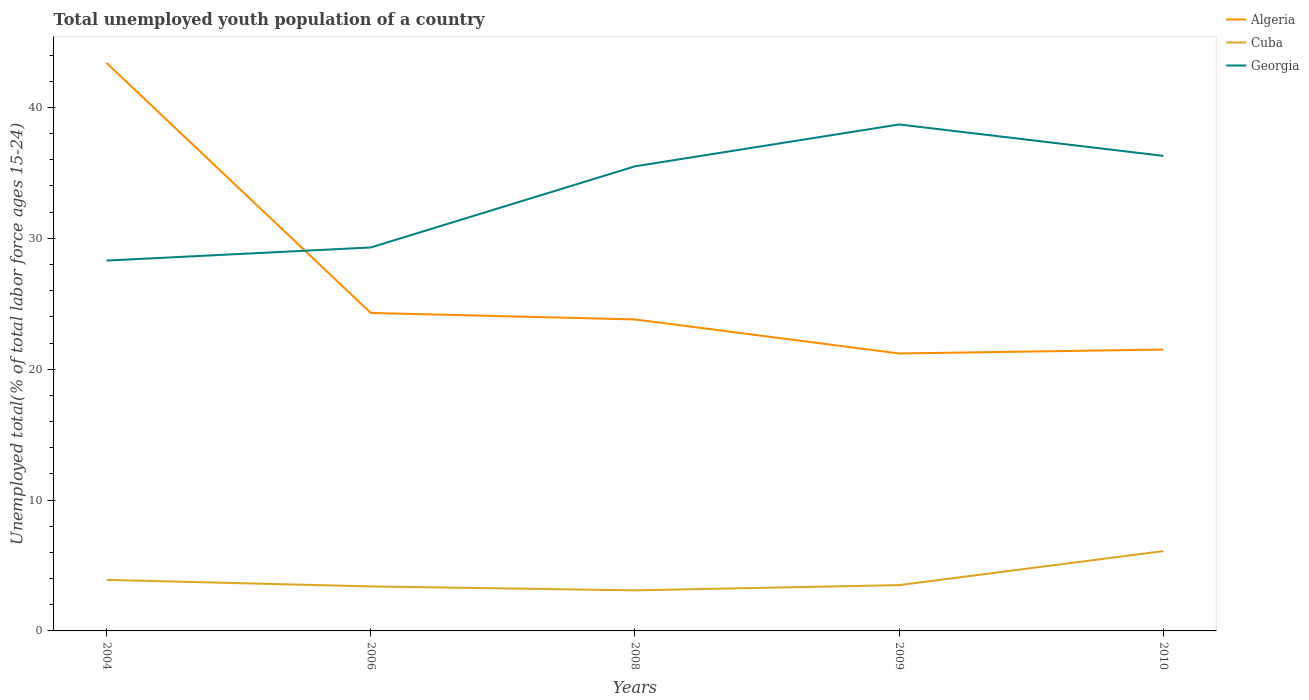How many different coloured lines are there?
Provide a short and direct response. 3. Does the line corresponding to Georgia intersect with the line corresponding to Cuba?
Your response must be concise. No. Is the number of lines equal to the number of legend labels?
Offer a terse response. Yes. Across all years, what is the maximum percentage of total unemployed youth population of a country in Georgia?
Provide a succinct answer. 28.3. In which year was the percentage of total unemployed youth population of a country in Algeria maximum?
Your answer should be compact. 2009. What is the total percentage of total unemployed youth population of a country in Algeria in the graph?
Keep it short and to the point. -0.3. What is the difference between the highest and the second highest percentage of total unemployed youth population of a country in Georgia?
Offer a very short reply. 10.4. What is the difference between the highest and the lowest percentage of total unemployed youth population of a country in Cuba?
Ensure brevity in your answer.  1. How many lines are there?
Ensure brevity in your answer.  3. What is the difference between two consecutive major ticks on the Y-axis?
Offer a terse response. 10. Does the graph contain any zero values?
Offer a very short reply. No. What is the title of the graph?
Provide a succinct answer. Total unemployed youth population of a country. Does "Jordan" appear as one of the legend labels in the graph?
Make the answer very short. No. What is the label or title of the X-axis?
Give a very brief answer. Years. What is the label or title of the Y-axis?
Your answer should be compact. Unemployed total(% of total labor force ages 15-24). What is the Unemployed total(% of total labor force ages 15-24) of Algeria in 2004?
Offer a terse response. 43.4. What is the Unemployed total(% of total labor force ages 15-24) of Cuba in 2004?
Your answer should be compact. 3.9. What is the Unemployed total(% of total labor force ages 15-24) of Georgia in 2004?
Keep it short and to the point. 28.3. What is the Unemployed total(% of total labor force ages 15-24) in Algeria in 2006?
Provide a succinct answer. 24.3. What is the Unemployed total(% of total labor force ages 15-24) of Cuba in 2006?
Ensure brevity in your answer.  3.4. What is the Unemployed total(% of total labor force ages 15-24) in Georgia in 2006?
Offer a very short reply. 29.3. What is the Unemployed total(% of total labor force ages 15-24) in Algeria in 2008?
Offer a very short reply. 23.8. What is the Unemployed total(% of total labor force ages 15-24) in Cuba in 2008?
Keep it short and to the point. 3.1. What is the Unemployed total(% of total labor force ages 15-24) in Georgia in 2008?
Keep it short and to the point. 35.5. What is the Unemployed total(% of total labor force ages 15-24) in Algeria in 2009?
Provide a succinct answer. 21.2. What is the Unemployed total(% of total labor force ages 15-24) of Georgia in 2009?
Provide a succinct answer. 38.7. What is the Unemployed total(% of total labor force ages 15-24) in Cuba in 2010?
Ensure brevity in your answer.  6.1. What is the Unemployed total(% of total labor force ages 15-24) of Georgia in 2010?
Your answer should be compact. 36.3. Across all years, what is the maximum Unemployed total(% of total labor force ages 15-24) in Algeria?
Your response must be concise. 43.4. Across all years, what is the maximum Unemployed total(% of total labor force ages 15-24) in Cuba?
Your answer should be compact. 6.1. Across all years, what is the maximum Unemployed total(% of total labor force ages 15-24) in Georgia?
Your answer should be very brief. 38.7. Across all years, what is the minimum Unemployed total(% of total labor force ages 15-24) in Algeria?
Ensure brevity in your answer.  21.2. Across all years, what is the minimum Unemployed total(% of total labor force ages 15-24) of Cuba?
Your answer should be very brief. 3.1. Across all years, what is the minimum Unemployed total(% of total labor force ages 15-24) of Georgia?
Offer a very short reply. 28.3. What is the total Unemployed total(% of total labor force ages 15-24) of Algeria in the graph?
Offer a very short reply. 134.2. What is the total Unemployed total(% of total labor force ages 15-24) in Georgia in the graph?
Your response must be concise. 168.1. What is the difference between the Unemployed total(% of total labor force ages 15-24) of Cuba in 2004 and that in 2006?
Offer a very short reply. 0.5. What is the difference between the Unemployed total(% of total labor force ages 15-24) in Georgia in 2004 and that in 2006?
Provide a short and direct response. -1. What is the difference between the Unemployed total(% of total labor force ages 15-24) of Algeria in 2004 and that in 2008?
Provide a short and direct response. 19.6. What is the difference between the Unemployed total(% of total labor force ages 15-24) in Cuba in 2004 and that in 2008?
Provide a succinct answer. 0.8. What is the difference between the Unemployed total(% of total labor force ages 15-24) in Georgia in 2004 and that in 2009?
Make the answer very short. -10.4. What is the difference between the Unemployed total(% of total labor force ages 15-24) of Algeria in 2004 and that in 2010?
Offer a terse response. 21.9. What is the difference between the Unemployed total(% of total labor force ages 15-24) in Georgia in 2004 and that in 2010?
Make the answer very short. -8. What is the difference between the Unemployed total(% of total labor force ages 15-24) in Georgia in 2006 and that in 2008?
Your response must be concise. -6.2. What is the difference between the Unemployed total(% of total labor force ages 15-24) in Algeria in 2006 and that in 2009?
Offer a very short reply. 3.1. What is the difference between the Unemployed total(% of total labor force ages 15-24) of Georgia in 2006 and that in 2009?
Ensure brevity in your answer.  -9.4. What is the difference between the Unemployed total(% of total labor force ages 15-24) in Algeria in 2006 and that in 2010?
Give a very brief answer. 2.8. What is the difference between the Unemployed total(% of total labor force ages 15-24) of Georgia in 2006 and that in 2010?
Your answer should be very brief. -7. What is the difference between the Unemployed total(% of total labor force ages 15-24) of Algeria in 2008 and that in 2009?
Give a very brief answer. 2.6. What is the difference between the Unemployed total(% of total labor force ages 15-24) in Cuba in 2008 and that in 2009?
Provide a short and direct response. -0.4. What is the difference between the Unemployed total(% of total labor force ages 15-24) of Georgia in 2008 and that in 2009?
Provide a succinct answer. -3.2. What is the difference between the Unemployed total(% of total labor force ages 15-24) of Algeria in 2008 and that in 2010?
Make the answer very short. 2.3. What is the difference between the Unemployed total(% of total labor force ages 15-24) in Cuba in 2008 and that in 2010?
Your response must be concise. -3. What is the difference between the Unemployed total(% of total labor force ages 15-24) of Georgia in 2008 and that in 2010?
Provide a succinct answer. -0.8. What is the difference between the Unemployed total(% of total labor force ages 15-24) of Algeria in 2009 and that in 2010?
Provide a succinct answer. -0.3. What is the difference between the Unemployed total(% of total labor force ages 15-24) in Cuba in 2004 and the Unemployed total(% of total labor force ages 15-24) in Georgia in 2006?
Offer a terse response. -25.4. What is the difference between the Unemployed total(% of total labor force ages 15-24) in Algeria in 2004 and the Unemployed total(% of total labor force ages 15-24) in Cuba in 2008?
Your answer should be compact. 40.3. What is the difference between the Unemployed total(% of total labor force ages 15-24) in Algeria in 2004 and the Unemployed total(% of total labor force ages 15-24) in Georgia in 2008?
Keep it short and to the point. 7.9. What is the difference between the Unemployed total(% of total labor force ages 15-24) of Cuba in 2004 and the Unemployed total(% of total labor force ages 15-24) of Georgia in 2008?
Make the answer very short. -31.6. What is the difference between the Unemployed total(% of total labor force ages 15-24) of Algeria in 2004 and the Unemployed total(% of total labor force ages 15-24) of Cuba in 2009?
Make the answer very short. 39.9. What is the difference between the Unemployed total(% of total labor force ages 15-24) of Algeria in 2004 and the Unemployed total(% of total labor force ages 15-24) of Georgia in 2009?
Provide a short and direct response. 4.7. What is the difference between the Unemployed total(% of total labor force ages 15-24) of Cuba in 2004 and the Unemployed total(% of total labor force ages 15-24) of Georgia in 2009?
Your answer should be compact. -34.8. What is the difference between the Unemployed total(% of total labor force ages 15-24) of Algeria in 2004 and the Unemployed total(% of total labor force ages 15-24) of Cuba in 2010?
Give a very brief answer. 37.3. What is the difference between the Unemployed total(% of total labor force ages 15-24) in Algeria in 2004 and the Unemployed total(% of total labor force ages 15-24) in Georgia in 2010?
Offer a terse response. 7.1. What is the difference between the Unemployed total(% of total labor force ages 15-24) of Cuba in 2004 and the Unemployed total(% of total labor force ages 15-24) of Georgia in 2010?
Provide a short and direct response. -32.4. What is the difference between the Unemployed total(% of total labor force ages 15-24) of Algeria in 2006 and the Unemployed total(% of total labor force ages 15-24) of Cuba in 2008?
Offer a very short reply. 21.2. What is the difference between the Unemployed total(% of total labor force ages 15-24) of Cuba in 2006 and the Unemployed total(% of total labor force ages 15-24) of Georgia in 2008?
Your response must be concise. -32.1. What is the difference between the Unemployed total(% of total labor force ages 15-24) of Algeria in 2006 and the Unemployed total(% of total labor force ages 15-24) of Cuba in 2009?
Offer a terse response. 20.8. What is the difference between the Unemployed total(% of total labor force ages 15-24) of Algeria in 2006 and the Unemployed total(% of total labor force ages 15-24) of Georgia in 2009?
Your response must be concise. -14.4. What is the difference between the Unemployed total(% of total labor force ages 15-24) in Cuba in 2006 and the Unemployed total(% of total labor force ages 15-24) in Georgia in 2009?
Give a very brief answer. -35.3. What is the difference between the Unemployed total(% of total labor force ages 15-24) of Algeria in 2006 and the Unemployed total(% of total labor force ages 15-24) of Georgia in 2010?
Provide a short and direct response. -12. What is the difference between the Unemployed total(% of total labor force ages 15-24) of Cuba in 2006 and the Unemployed total(% of total labor force ages 15-24) of Georgia in 2010?
Your response must be concise. -32.9. What is the difference between the Unemployed total(% of total labor force ages 15-24) in Algeria in 2008 and the Unemployed total(% of total labor force ages 15-24) in Cuba in 2009?
Give a very brief answer. 20.3. What is the difference between the Unemployed total(% of total labor force ages 15-24) of Algeria in 2008 and the Unemployed total(% of total labor force ages 15-24) of Georgia in 2009?
Offer a very short reply. -14.9. What is the difference between the Unemployed total(% of total labor force ages 15-24) of Cuba in 2008 and the Unemployed total(% of total labor force ages 15-24) of Georgia in 2009?
Provide a succinct answer. -35.6. What is the difference between the Unemployed total(% of total labor force ages 15-24) in Algeria in 2008 and the Unemployed total(% of total labor force ages 15-24) in Cuba in 2010?
Your answer should be very brief. 17.7. What is the difference between the Unemployed total(% of total labor force ages 15-24) in Cuba in 2008 and the Unemployed total(% of total labor force ages 15-24) in Georgia in 2010?
Your answer should be compact. -33.2. What is the difference between the Unemployed total(% of total labor force ages 15-24) in Algeria in 2009 and the Unemployed total(% of total labor force ages 15-24) in Georgia in 2010?
Provide a short and direct response. -15.1. What is the difference between the Unemployed total(% of total labor force ages 15-24) in Cuba in 2009 and the Unemployed total(% of total labor force ages 15-24) in Georgia in 2010?
Keep it short and to the point. -32.8. What is the average Unemployed total(% of total labor force ages 15-24) of Algeria per year?
Provide a succinct answer. 26.84. What is the average Unemployed total(% of total labor force ages 15-24) of Cuba per year?
Give a very brief answer. 4. What is the average Unemployed total(% of total labor force ages 15-24) of Georgia per year?
Offer a very short reply. 33.62. In the year 2004, what is the difference between the Unemployed total(% of total labor force ages 15-24) in Algeria and Unemployed total(% of total labor force ages 15-24) in Cuba?
Provide a succinct answer. 39.5. In the year 2004, what is the difference between the Unemployed total(% of total labor force ages 15-24) in Cuba and Unemployed total(% of total labor force ages 15-24) in Georgia?
Your answer should be compact. -24.4. In the year 2006, what is the difference between the Unemployed total(% of total labor force ages 15-24) of Algeria and Unemployed total(% of total labor force ages 15-24) of Cuba?
Make the answer very short. 20.9. In the year 2006, what is the difference between the Unemployed total(% of total labor force ages 15-24) of Algeria and Unemployed total(% of total labor force ages 15-24) of Georgia?
Give a very brief answer. -5. In the year 2006, what is the difference between the Unemployed total(% of total labor force ages 15-24) in Cuba and Unemployed total(% of total labor force ages 15-24) in Georgia?
Give a very brief answer. -25.9. In the year 2008, what is the difference between the Unemployed total(% of total labor force ages 15-24) of Algeria and Unemployed total(% of total labor force ages 15-24) of Cuba?
Offer a very short reply. 20.7. In the year 2008, what is the difference between the Unemployed total(% of total labor force ages 15-24) of Cuba and Unemployed total(% of total labor force ages 15-24) of Georgia?
Make the answer very short. -32.4. In the year 2009, what is the difference between the Unemployed total(% of total labor force ages 15-24) in Algeria and Unemployed total(% of total labor force ages 15-24) in Georgia?
Your answer should be very brief. -17.5. In the year 2009, what is the difference between the Unemployed total(% of total labor force ages 15-24) of Cuba and Unemployed total(% of total labor force ages 15-24) of Georgia?
Give a very brief answer. -35.2. In the year 2010, what is the difference between the Unemployed total(% of total labor force ages 15-24) in Algeria and Unemployed total(% of total labor force ages 15-24) in Cuba?
Provide a succinct answer. 15.4. In the year 2010, what is the difference between the Unemployed total(% of total labor force ages 15-24) in Algeria and Unemployed total(% of total labor force ages 15-24) in Georgia?
Your response must be concise. -14.8. In the year 2010, what is the difference between the Unemployed total(% of total labor force ages 15-24) in Cuba and Unemployed total(% of total labor force ages 15-24) in Georgia?
Give a very brief answer. -30.2. What is the ratio of the Unemployed total(% of total labor force ages 15-24) of Algeria in 2004 to that in 2006?
Your answer should be compact. 1.79. What is the ratio of the Unemployed total(% of total labor force ages 15-24) in Cuba in 2004 to that in 2006?
Give a very brief answer. 1.15. What is the ratio of the Unemployed total(% of total labor force ages 15-24) of Georgia in 2004 to that in 2006?
Your answer should be very brief. 0.97. What is the ratio of the Unemployed total(% of total labor force ages 15-24) of Algeria in 2004 to that in 2008?
Ensure brevity in your answer.  1.82. What is the ratio of the Unemployed total(% of total labor force ages 15-24) in Cuba in 2004 to that in 2008?
Keep it short and to the point. 1.26. What is the ratio of the Unemployed total(% of total labor force ages 15-24) of Georgia in 2004 to that in 2008?
Your response must be concise. 0.8. What is the ratio of the Unemployed total(% of total labor force ages 15-24) in Algeria in 2004 to that in 2009?
Your answer should be very brief. 2.05. What is the ratio of the Unemployed total(% of total labor force ages 15-24) in Cuba in 2004 to that in 2009?
Your answer should be compact. 1.11. What is the ratio of the Unemployed total(% of total labor force ages 15-24) in Georgia in 2004 to that in 2009?
Provide a short and direct response. 0.73. What is the ratio of the Unemployed total(% of total labor force ages 15-24) of Algeria in 2004 to that in 2010?
Make the answer very short. 2.02. What is the ratio of the Unemployed total(% of total labor force ages 15-24) in Cuba in 2004 to that in 2010?
Provide a short and direct response. 0.64. What is the ratio of the Unemployed total(% of total labor force ages 15-24) of Georgia in 2004 to that in 2010?
Your response must be concise. 0.78. What is the ratio of the Unemployed total(% of total labor force ages 15-24) in Cuba in 2006 to that in 2008?
Your answer should be compact. 1.1. What is the ratio of the Unemployed total(% of total labor force ages 15-24) of Georgia in 2006 to that in 2008?
Make the answer very short. 0.83. What is the ratio of the Unemployed total(% of total labor force ages 15-24) of Algeria in 2006 to that in 2009?
Keep it short and to the point. 1.15. What is the ratio of the Unemployed total(% of total labor force ages 15-24) in Cuba in 2006 to that in 2009?
Give a very brief answer. 0.97. What is the ratio of the Unemployed total(% of total labor force ages 15-24) in Georgia in 2006 to that in 2009?
Keep it short and to the point. 0.76. What is the ratio of the Unemployed total(% of total labor force ages 15-24) in Algeria in 2006 to that in 2010?
Offer a terse response. 1.13. What is the ratio of the Unemployed total(% of total labor force ages 15-24) in Cuba in 2006 to that in 2010?
Your answer should be compact. 0.56. What is the ratio of the Unemployed total(% of total labor force ages 15-24) of Georgia in 2006 to that in 2010?
Make the answer very short. 0.81. What is the ratio of the Unemployed total(% of total labor force ages 15-24) in Algeria in 2008 to that in 2009?
Offer a very short reply. 1.12. What is the ratio of the Unemployed total(% of total labor force ages 15-24) of Cuba in 2008 to that in 2009?
Give a very brief answer. 0.89. What is the ratio of the Unemployed total(% of total labor force ages 15-24) of Georgia in 2008 to that in 2009?
Your answer should be very brief. 0.92. What is the ratio of the Unemployed total(% of total labor force ages 15-24) in Algeria in 2008 to that in 2010?
Provide a short and direct response. 1.11. What is the ratio of the Unemployed total(% of total labor force ages 15-24) of Cuba in 2008 to that in 2010?
Ensure brevity in your answer.  0.51. What is the ratio of the Unemployed total(% of total labor force ages 15-24) of Algeria in 2009 to that in 2010?
Offer a terse response. 0.99. What is the ratio of the Unemployed total(% of total labor force ages 15-24) in Cuba in 2009 to that in 2010?
Make the answer very short. 0.57. What is the ratio of the Unemployed total(% of total labor force ages 15-24) in Georgia in 2009 to that in 2010?
Provide a succinct answer. 1.07. What is the difference between the highest and the second highest Unemployed total(% of total labor force ages 15-24) of Algeria?
Your answer should be very brief. 19.1. What is the difference between the highest and the second highest Unemployed total(% of total labor force ages 15-24) in Cuba?
Your answer should be very brief. 2.2. What is the difference between the highest and the lowest Unemployed total(% of total labor force ages 15-24) in Cuba?
Offer a very short reply. 3. 